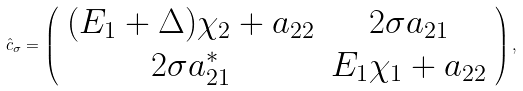<formula> <loc_0><loc_0><loc_500><loc_500>\hat { c } _ { \sigma } = \left ( \begin{array} { c c } ( E _ { 1 } + \Delta ) \chi _ { 2 } + a _ { 2 2 } & 2 \sigma a _ { 2 1 } \\ 2 \sigma a _ { 2 1 } ^ { * } & E _ { 1 } \chi _ { 1 } + a _ { 2 2 } \end{array} \right ) ,</formula> 